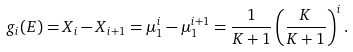Convert formula to latex. <formula><loc_0><loc_0><loc_500><loc_500>g _ { i } ( E ) = X _ { i } - X _ { i + 1 } = \mu _ { 1 } ^ { i } - \mu _ { 1 } ^ { i + 1 } = \frac { 1 } { K + 1 } \left ( \frac { K } { K + 1 } \right ) ^ { i } .</formula> 